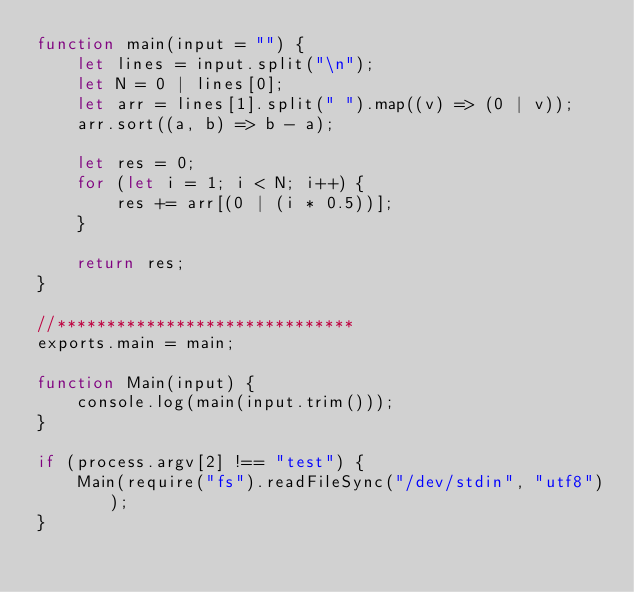<code> <loc_0><loc_0><loc_500><loc_500><_JavaScript_>function main(input = "") {
    let lines = input.split("\n");
    let N = 0 | lines[0];
    let arr = lines[1].split(" ").map((v) => (0 | v));
    arr.sort((a, b) => b - a);

    let res = 0;
    for (let i = 1; i < N; i++) {
        res += arr[(0 | (i * 0.5))];        
    }

    return res;
}

//******************************
exports.main = main;

function Main(input) {
    console.log(main(input.trim()));
}

if (process.argv[2] !== "test") {
    Main(require("fs").readFileSync("/dev/stdin", "utf8"));
}</code> 